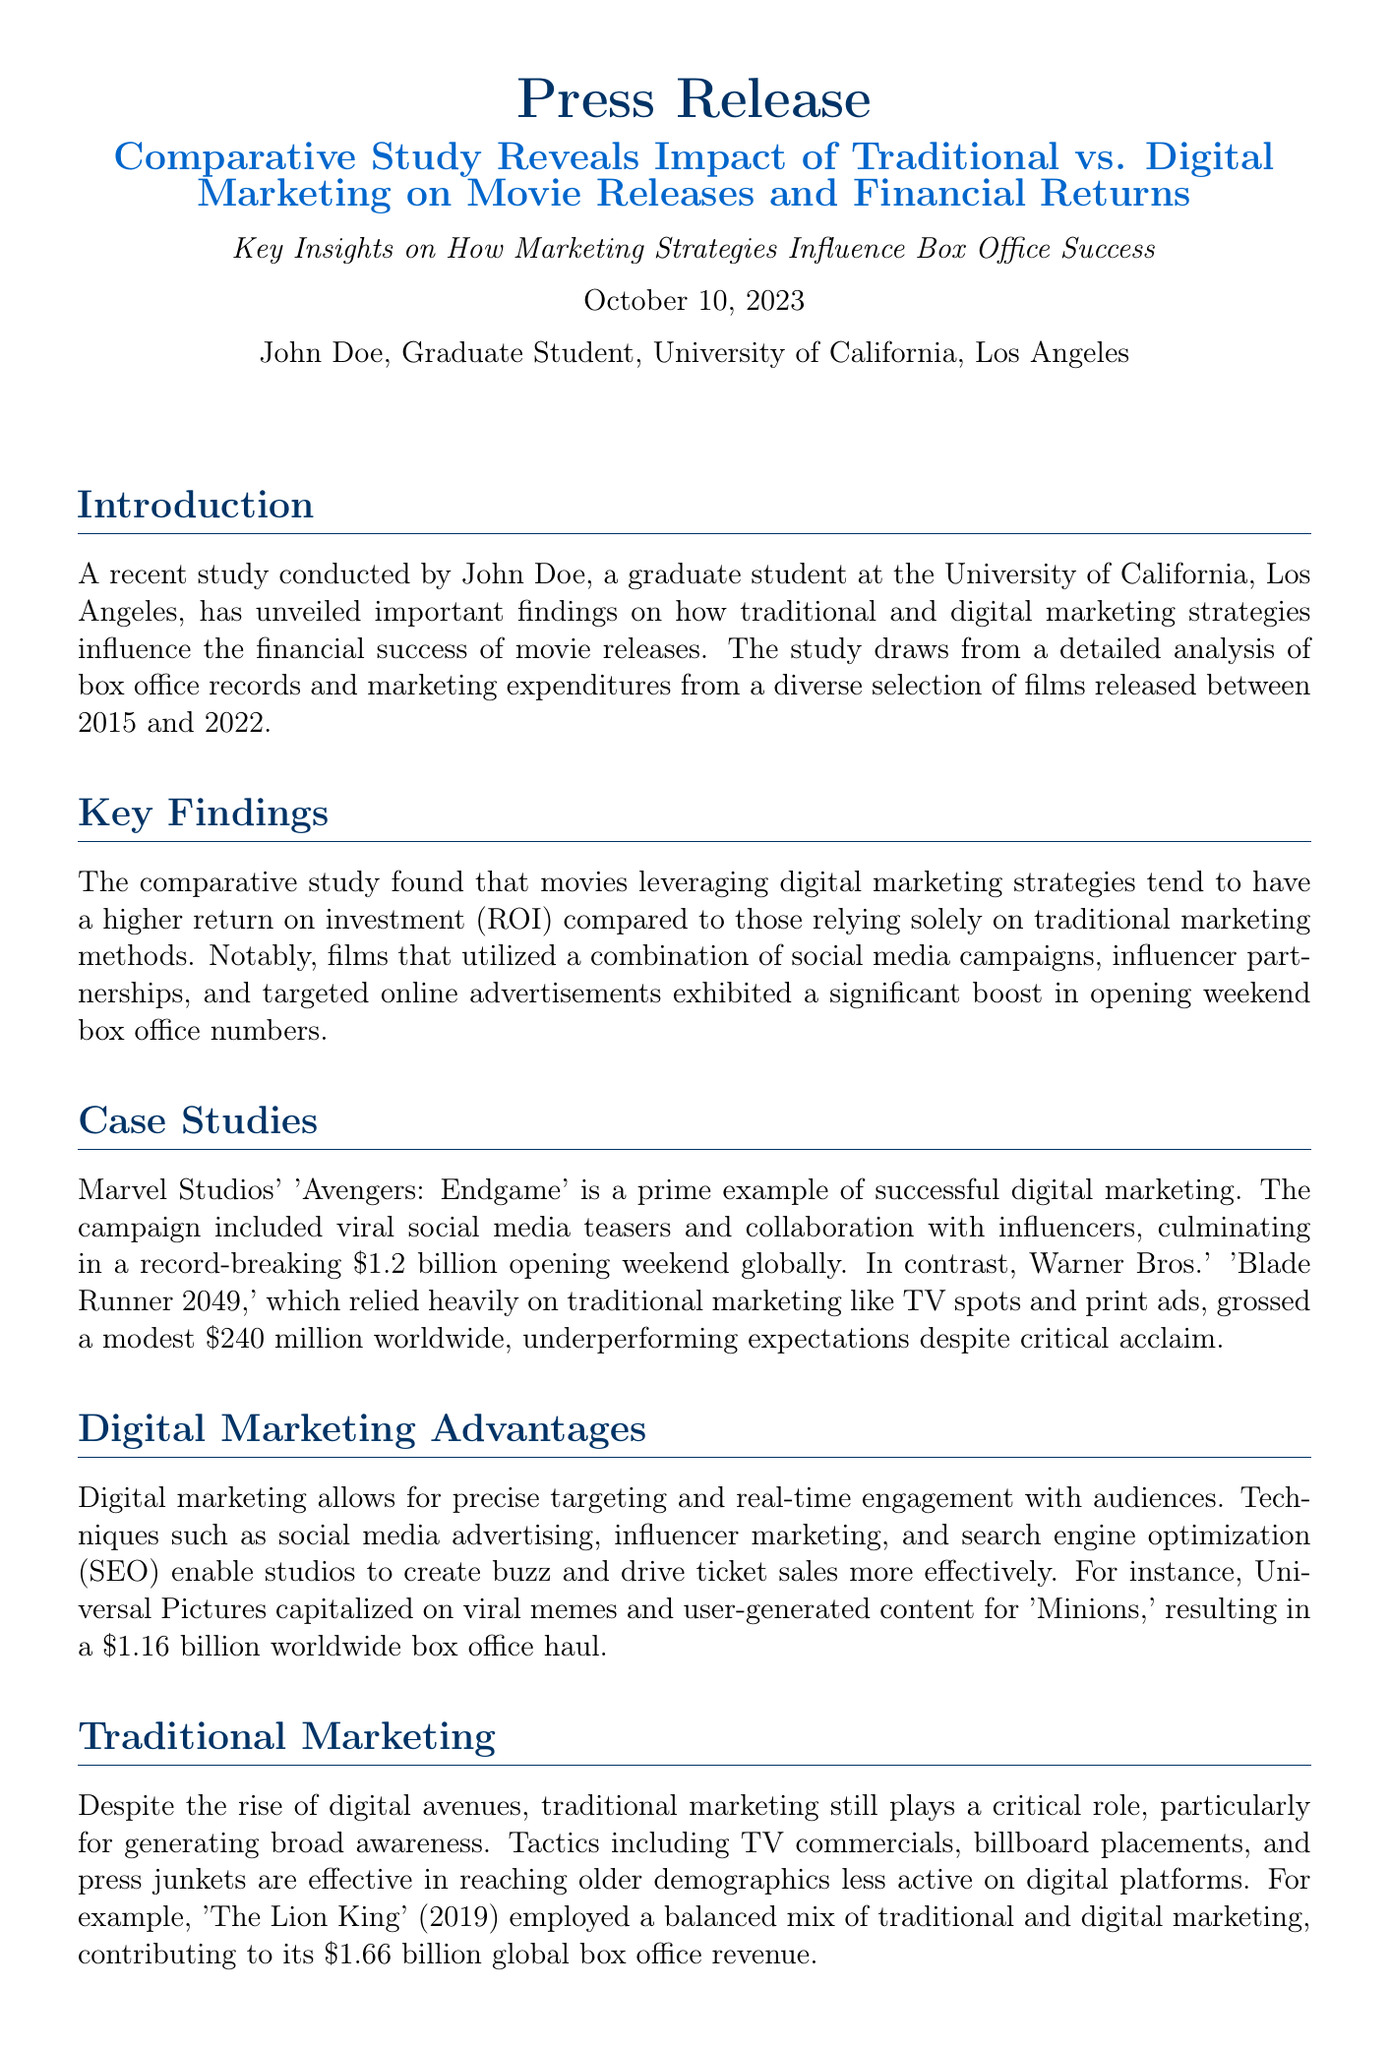What is the date of the press release? The date of the press release is mentioned in the introduction as October 10, 2023.
Answer: October 10, 2023 Who conducted the study? The study was conducted by John Doe, a graduate student at UCLA.
Answer: John Doe What is the box office gross of 'Avengers: Endgame'? The box office gross for 'Avengers: Endgame' is stated as a record-breaking $1.2 billion.
Answer: $1.2 billion What marketing strategy is highlighted as advantageous for box office success? The document emphasizes the use of digital marketing strategies as advantageous, including social media campaigns.
Answer: digital marketing How much did 'Blade Runner 2049' gross worldwide? The worldwide gross for 'Blade Runner 2049' is mentioned as $240 million.
Answer: $240 million What type of marketing does 'The Lion King' (2019) utilize? The document notes that 'The Lion King' (2019) employed a balanced mix of traditional and digital marketing strategies.
Answer: balanced mix What is the primary objective of the study? The study aims to reveal the impact of marketing strategies on the financial success of movie releases.
Answer: impact of marketing strategies Which film made $1.66 billion globally? The document states that 'The Lion King' (2019) made $1.66 billion globally.
Answer: The Lion King (2019) What is John's email address? The contact information provides his email address as johndoe@ucla.edu.
Answer: johndoe@ucla.edu 